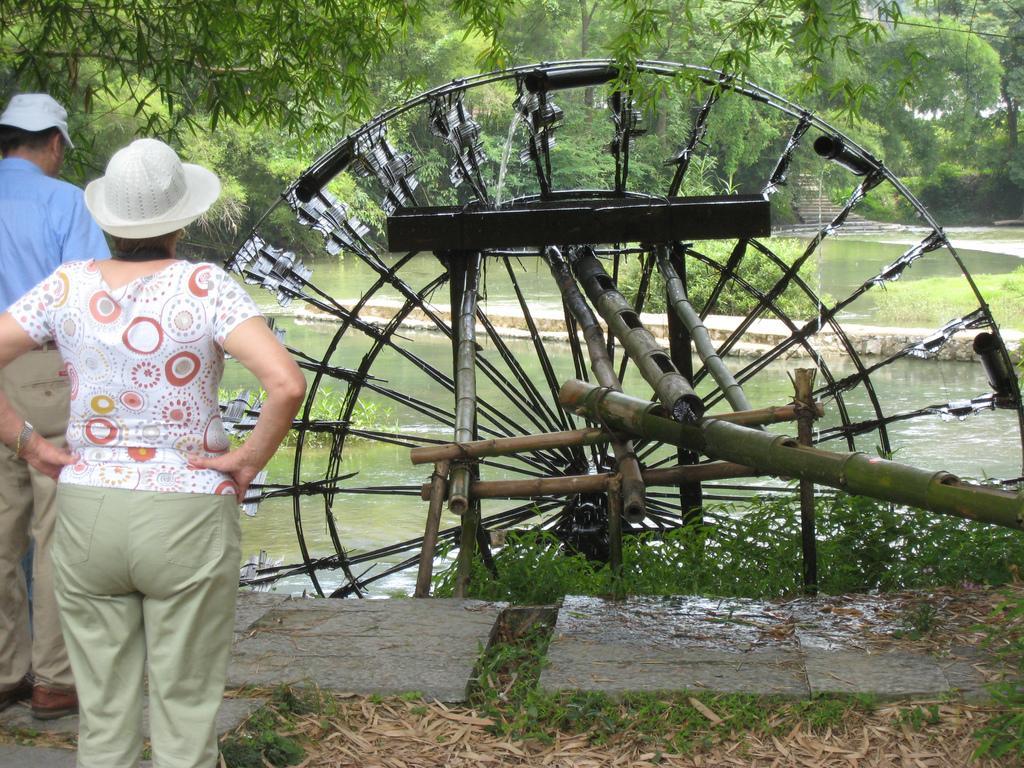Describe this image in one or two sentences. This image is taken outdoors. At the bottom of the image there is a floor and there is a ground with grass and dry leaves on it. On the left side of the image a man and a woman are standing on the floor. In the background there are many trees and plants. In the middle of the image there is a pond with water and there is a spinning wheel. 